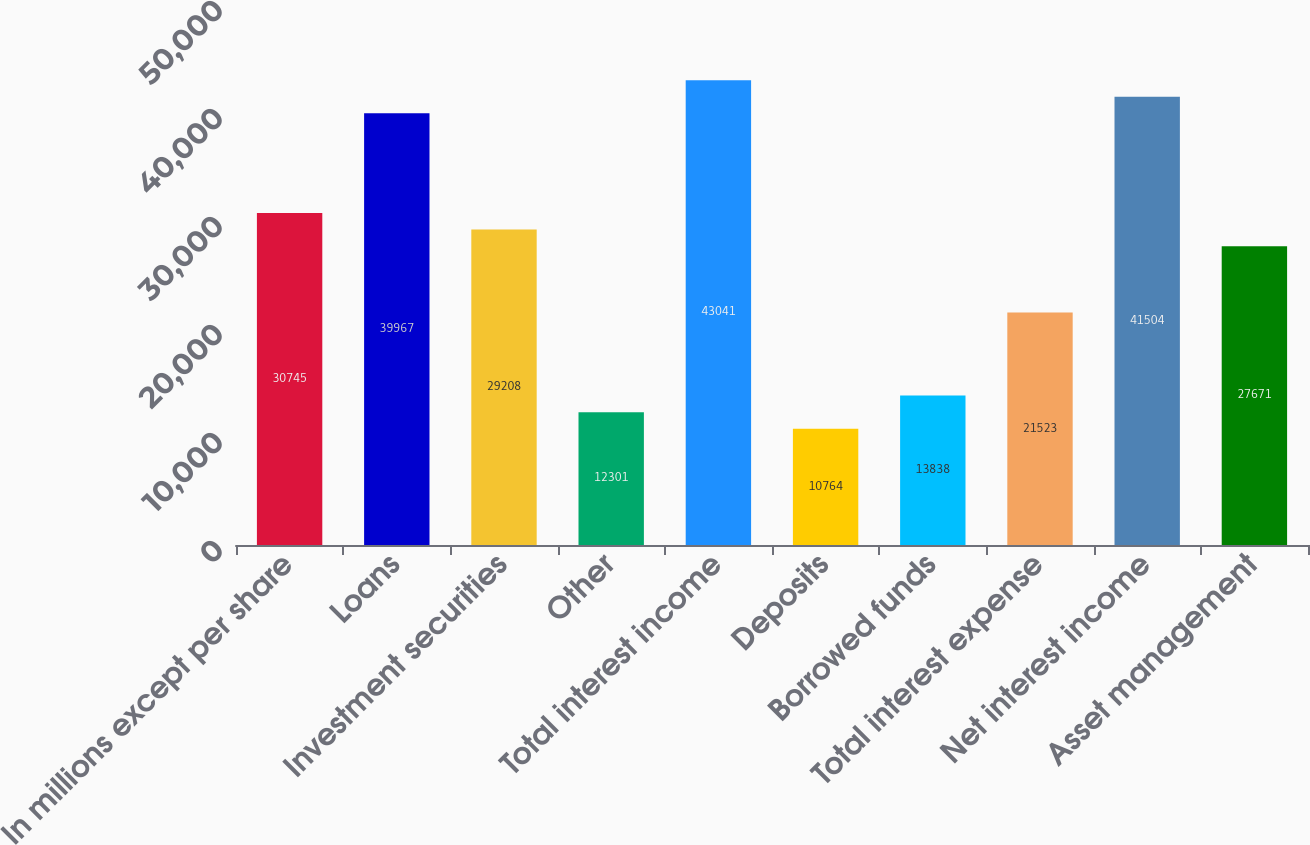Convert chart. <chart><loc_0><loc_0><loc_500><loc_500><bar_chart><fcel>In millions except per share<fcel>Loans<fcel>Investment securities<fcel>Other<fcel>Total interest income<fcel>Deposits<fcel>Borrowed funds<fcel>Total interest expense<fcel>Net interest income<fcel>Asset management<nl><fcel>30745<fcel>39967<fcel>29208<fcel>12301<fcel>43041<fcel>10764<fcel>13838<fcel>21523<fcel>41504<fcel>27671<nl></chart> 